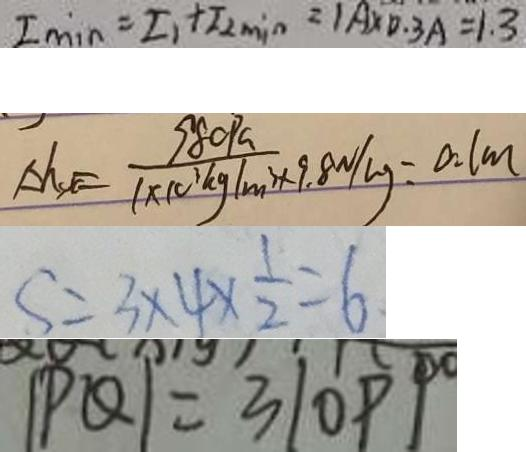Convert formula to latex. <formula><loc_0><loc_0><loc_500><loc_500>I \min = I _ { 1 } + I _ { 2 \min } = 1 A \times 0 . 3 A = 1 . 3 
 \Delta h _ { s t } = \frac { 9 8 0 P a } { 1 \times 1 0 ^ { 3 } k g / m ^ { 3 } \times 9 . 8 N / k g } = 0 . 1 m 
 S = 3 \times 4 \times \frac { 1 } { 2 } = 6 
 \vert P Q \vert = 3 \vert O P \vert</formula> 